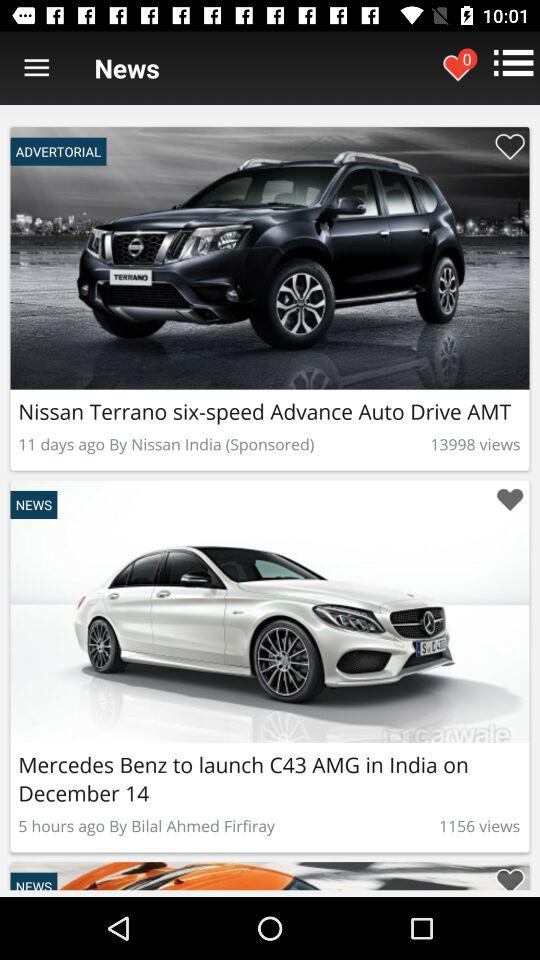How many views are there for Mercedes Benz? There are 1156 views. 